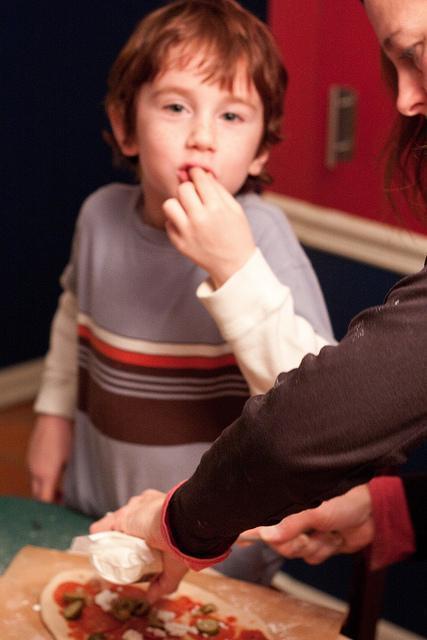How many people are in the picture?
Give a very brief answer. 2. 